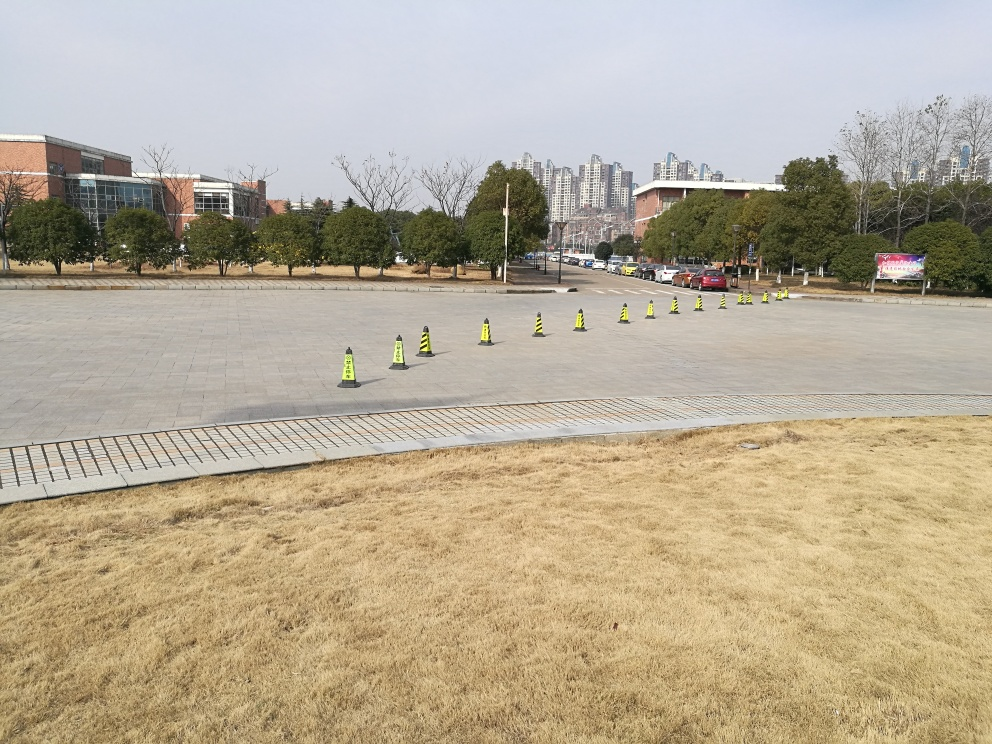Is the visibility of the obstacles clear? The visibility of the obstacles, which appear to be traffic cones, is high due to their bright color and significant size that contrasts with the surrounding environment. They're placed in a line across a wide, open plaza, indicating a clear separation between two areas, likely for organizing an event or guiding pedestrian traffic. 